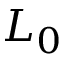Convert formula to latex. <formula><loc_0><loc_0><loc_500><loc_500>L _ { 0 }</formula> 